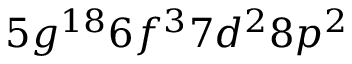<formula> <loc_0><loc_0><loc_500><loc_500>5 g ^ { 1 8 } 6 f ^ { 3 } 7 d ^ { 2 } 8 p ^ { 2 }</formula> 